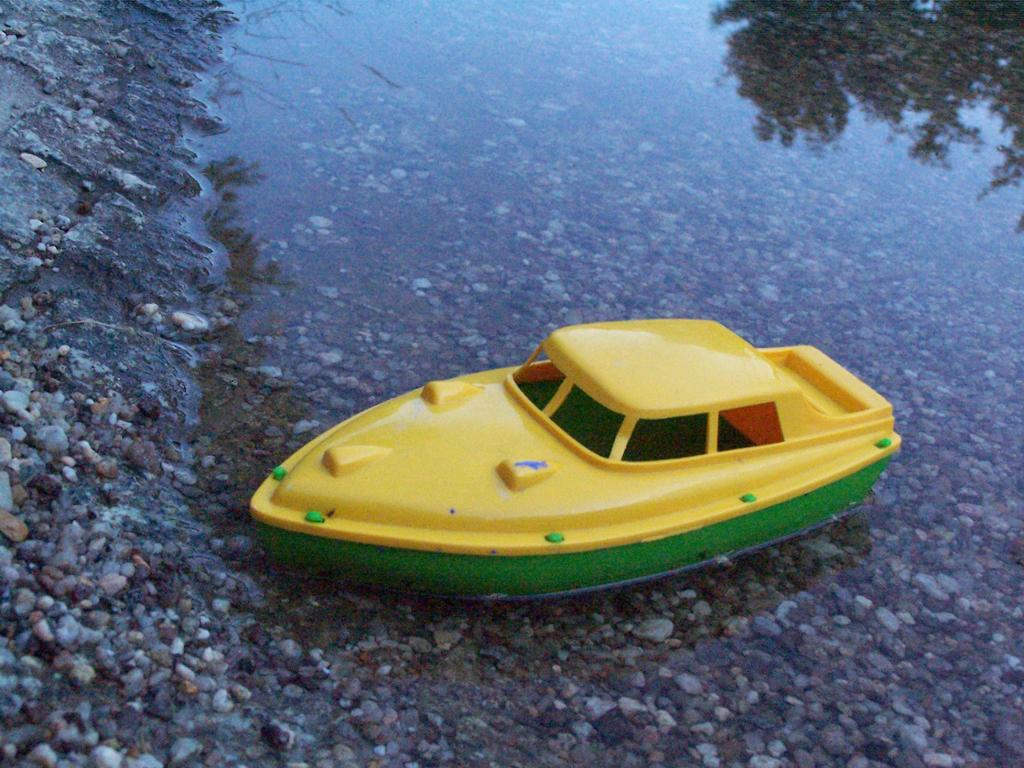What is the main subject in the center of the image? There is a boat in the water in the center of the image. What can be seen on the left side of the image? There are stones on the left side of the image. What type of badge is being awarded to the boat in the image? There is no badge or award ceremony depicted in the image; it simply shows a boat in the water and stones on the left side. 